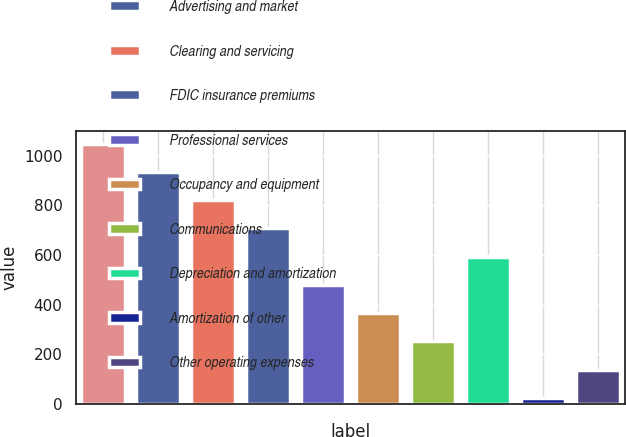<chart> <loc_0><loc_0><loc_500><loc_500><bar_chart><fcel>Compensation and benefits<fcel>Advertising and market<fcel>Clearing and servicing<fcel>FDIC insurance premiums<fcel>Professional services<fcel>Occupancy and equipment<fcel>Communications<fcel>Depreciation and amortization<fcel>Amortization of other<fcel>Other operating expenses<nl><fcel>1048.41<fcel>934.72<fcel>821.03<fcel>707.34<fcel>479.96<fcel>366.27<fcel>252.58<fcel>593.65<fcel>25.2<fcel>138.89<nl></chart> 